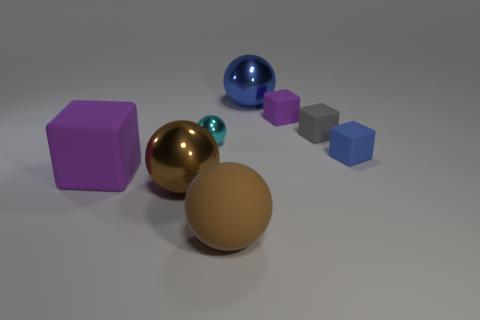Is there any other thing that is the same color as the large rubber cube?
Keep it short and to the point. Yes. Do the tiny cube that is to the right of the tiny gray thing and the large metallic sphere on the right side of the small shiny sphere have the same color?
Make the answer very short. Yes. Are there any big blue metallic spheres?
Keep it short and to the point. Yes. Are there any large things that have the same material as the cyan sphere?
Offer a terse response. Yes. Are there any other things that are the same material as the tiny gray object?
Ensure brevity in your answer.  Yes. The big cube has what color?
Offer a very short reply. Purple. There is a tiny object that is the same color as the big cube; what is its shape?
Your answer should be compact. Cube. There is a cube that is the same size as the rubber ball; what is its color?
Your answer should be very brief. Purple. How many metallic things are small purple things or large spheres?
Keep it short and to the point. 2. How many matte cubes are both in front of the small purple thing and to the right of the matte ball?
Give a very brief answer. 2. 